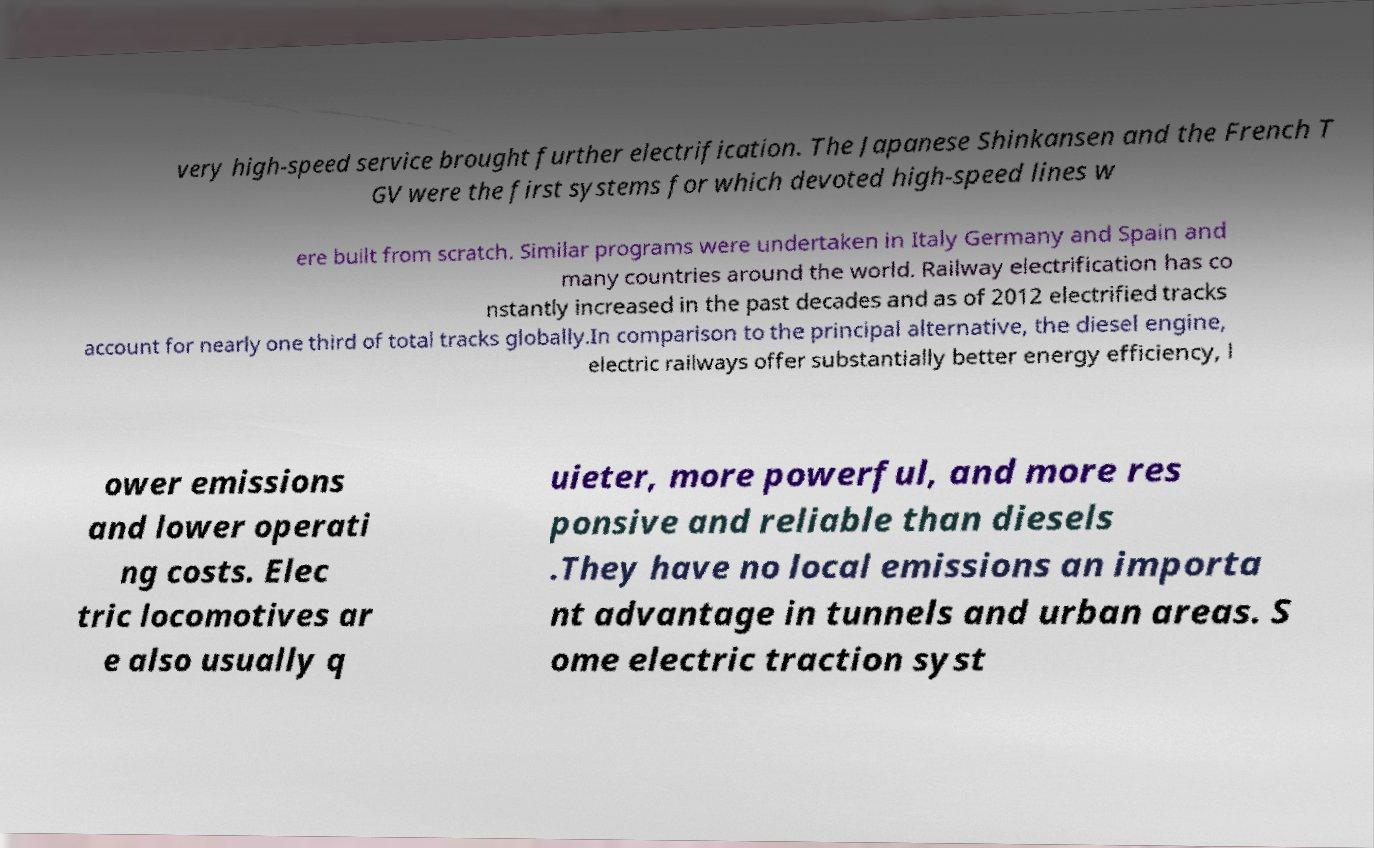What messages or text are displayed in this image? I need them in a readable, typed format. very high-speed service brought further electrification. The Japanese Shinkansen and the French T GV were the first systems for which devoted high-speed lines w ere built from scratch. Similar programs were undertaken in Italy Germany and Spain and many countries around the world. Railway electrification has co nstantly increased in the past decades and as of 2012 electrified tracks account for nearly one third of total tracks globally.In comparison to the principal alternative, the diesel engine, electric railways offer substantially better energy efficiency, l ower emissions and lower operati ng costs. Elec tric locomotives ar e also usually q uieter, more powerful, and more res ponsive and reliable than diesels .They have no local emissions an importa nt advantage in tunnels and urban areas. S ome electric traction syst 